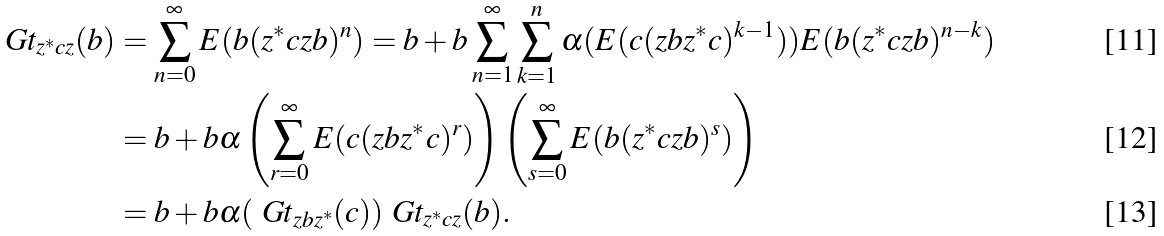<formula> <loc_0><loc_0><loc_500><loc_500>\ G t _ { z ^ { * } c z } ( b ) & = \sum _ { n = 0 } ^ { \infty } E ( b ( z ^ { * } c z b ) ^ { n } ) = b + b \sum _ { n = 1 } ^ { \infty } \sum _ { k = 1 } ^ { n } \alpha ( E ( c ( z b z ^ { * } c ) ^ { k - 1 } ) ) E ( b ( z ^ { * } c z b ) ^ { n - k } ) \\ & = b + b \alpha \left ( \sum _ { r = 0 } ^ { \infty } E ( c ( z b z ^ { * } c ) ^ { r } ) \right ) \left ( \sum _ { s = 0 } ^ { \infty } E ( b ( z ^ { * } c z b ) ^ { s } ) \right ) \\ & = b + b \alpha ( \ G t _ { z b z ^ { * } } ( c ) ) \ G t _ { z ^ { * } c z } ( b ) .</formula> 